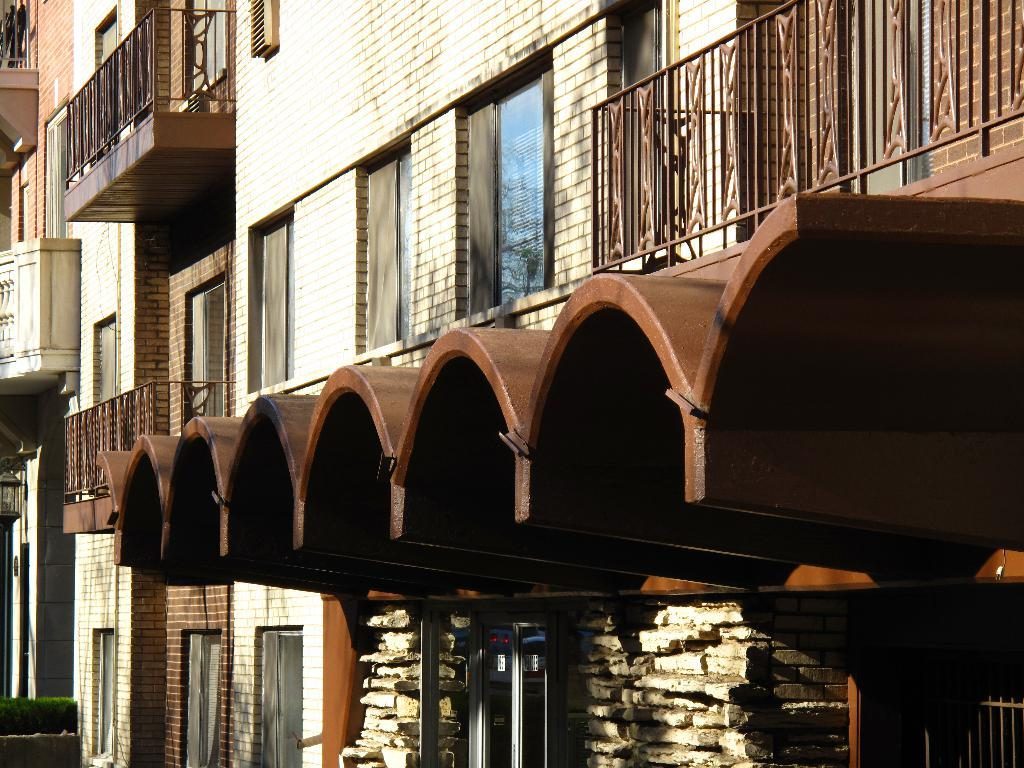What type of structure is present in the picture? There is a building in the picture. What material are the windows of the building made of? The building has glass windows. What type of railing is present on the building? The building has a steel railing. Can you describe another structure in the picture? There is a shelter in the picture. What arm is the coach using to hold the bat in the image? There is no coach or bat present in the image; it features of the building and shelter are the focus. 